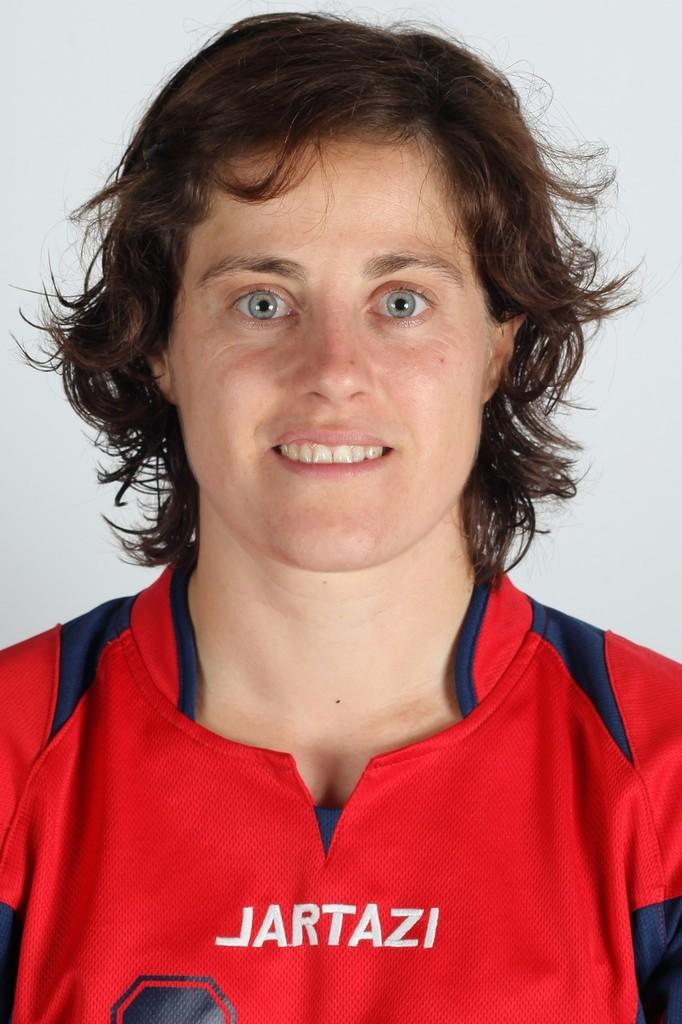<image>
Summarize the visual content of the image. A woman wearing a red jersey that says Jartazi on it. 